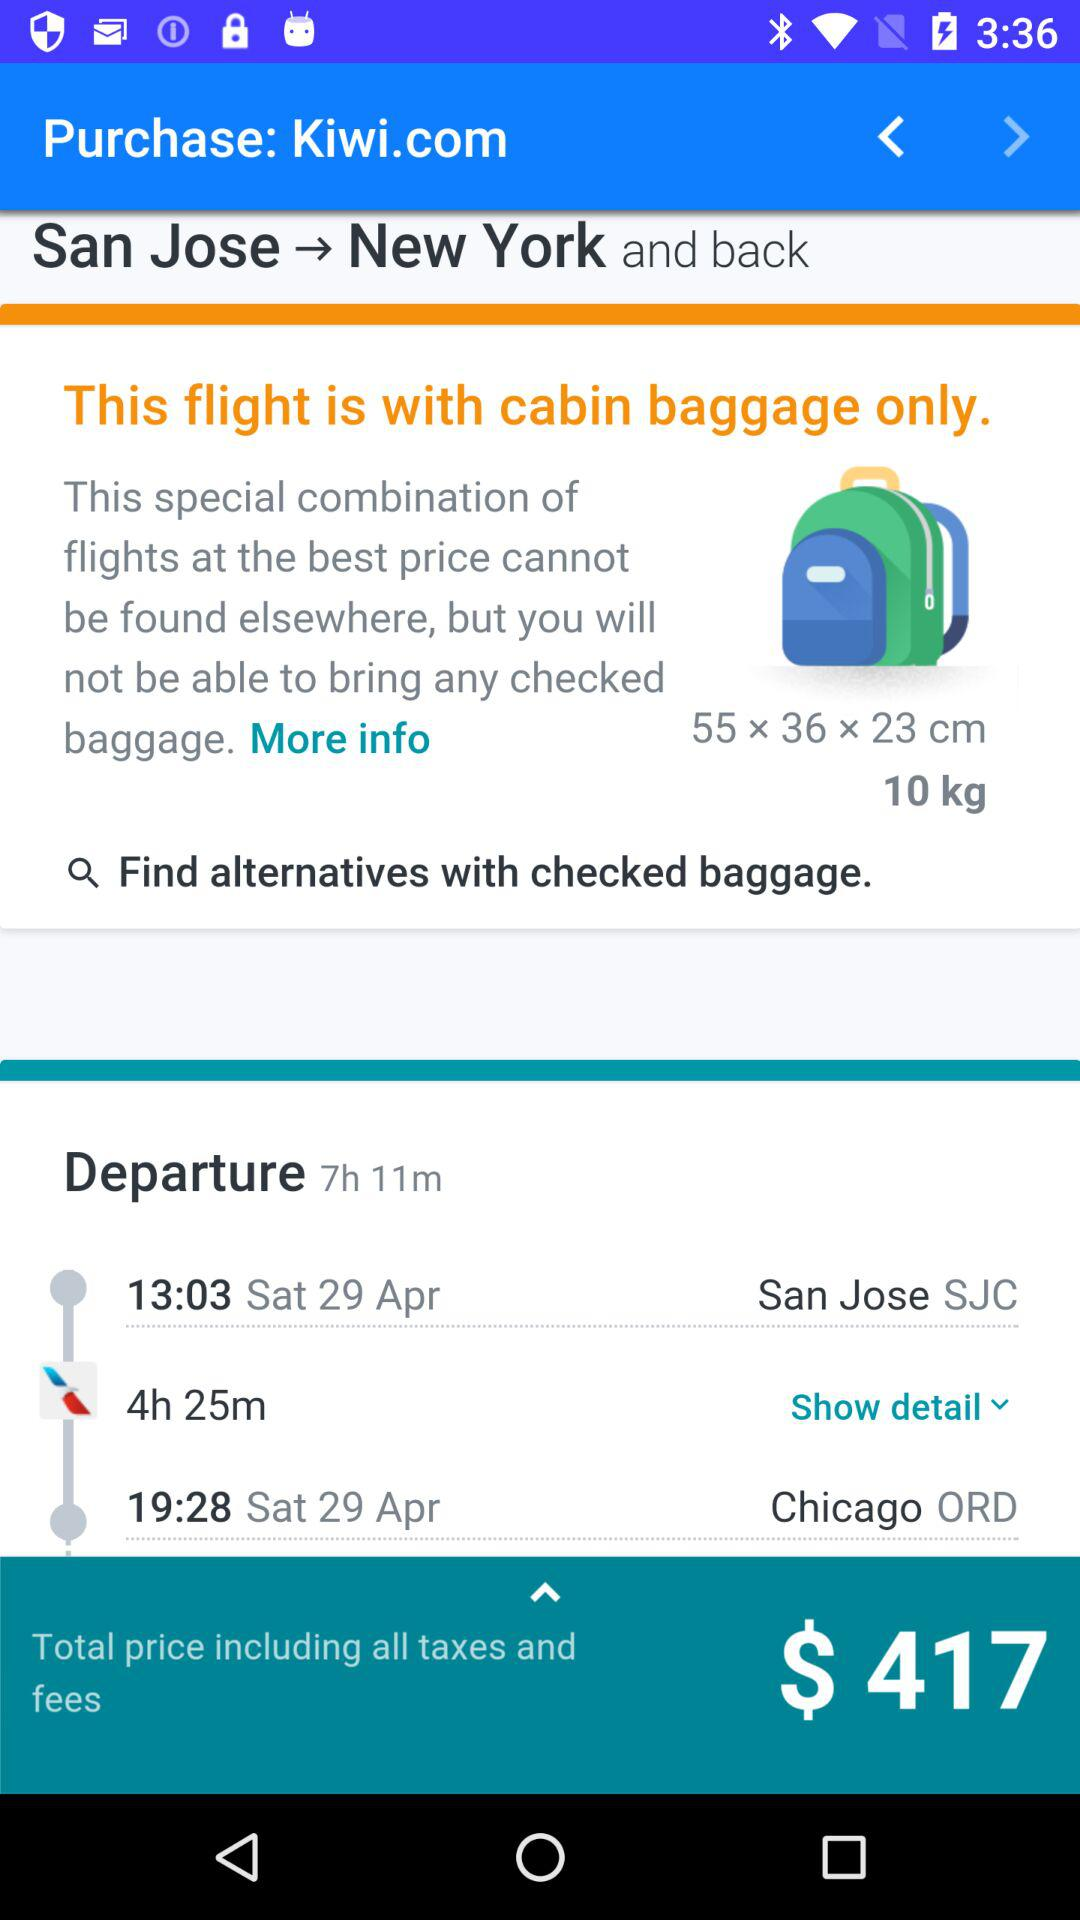What is the total travel price? The total travel price is $417. 